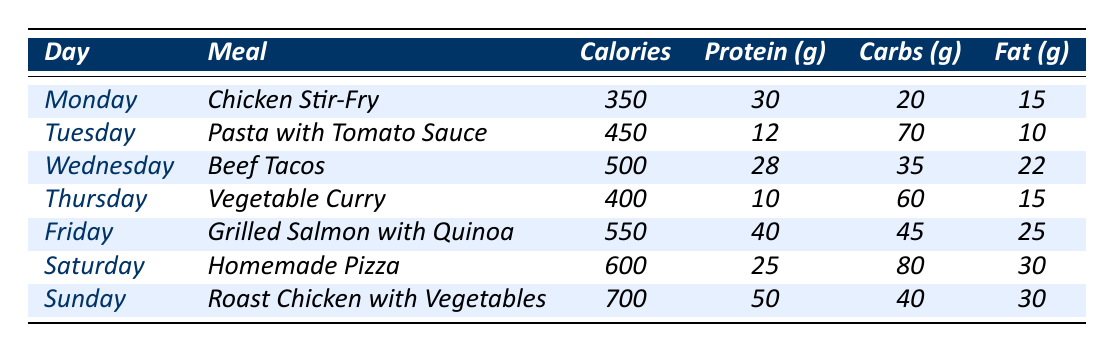What meal has the highest calorie count? By examining the "Calories" column in the table, I see that "Roast Chicken with Vegetables" on Sunday has the highest value at 700 calories.
Answer: Roast Chicken with Vegetables Which day has a meal consisting of pasta? Looking at the table, "Pasta with Tomato Sauce" is listed on Tuesday.
Answer: Tuesday What is the total protein intake for Monday and Tuesday combined? The protein values for Monday (30g) and Tuesday (12g) are added together: 30 + 12 = 42g.
Answer: 42g Is the meal on Wednesday higher in calories than the meal on Thursday? "Beef Tacos" on Wednesday has 500 calories, while "Vegetable Curry" on Thursday has 400 calories. Since 500 is greater than 400, the statement is true.
Answer: Yes What is the average calorie count for the meals over the week? Adding all the calories: 350 + 450 + 500 + 400 + 550 + 600 + 700 = 3550. Since there are 7 meals, the average is 3550 / 7 ≈ 507.14, which rounds to 507 for simplicity.
Answer: Approximately 507 Which meal has the least amount of fat? Checking the "Fat" column, "Pasta with Tomato Sauce" on Tuesday has the lowest value of 10g.
Answer: Pasta with Tomato Sauce How many meals have over 600 calories? Looking through the "Calories" column, the meals with over 600 calories are "Homemade Pizza" (600) and "Roast Chicken with Vegetables" (700). Therefore, there are 2 meals.
Answer: 2 What is the difference in protein content between the meal on Friday and the meal on Saturday? The protein value for Friday's meal "Grilled Salmon with Quinoa" is 40g and for Saturday's meal "Homemade Pizza," it is 25g. The difference is 40 - 25 = 15g.
Answer: 15g Is the carbohydrate content of "Vegetable Curry" more than that of "Chicken Stir-Fry"? "Vegetable Curry" has 60g of carbs while "Chicken Stir-Fry" has 20g. Since 60 is greater than 20, the statement is true.
Answer: Yes On which day do we consume the most protein? Looking at the protein values, "Roast Chicken with Vegetables" on Sunday has the highest at 50g.
Answer: Sunday 